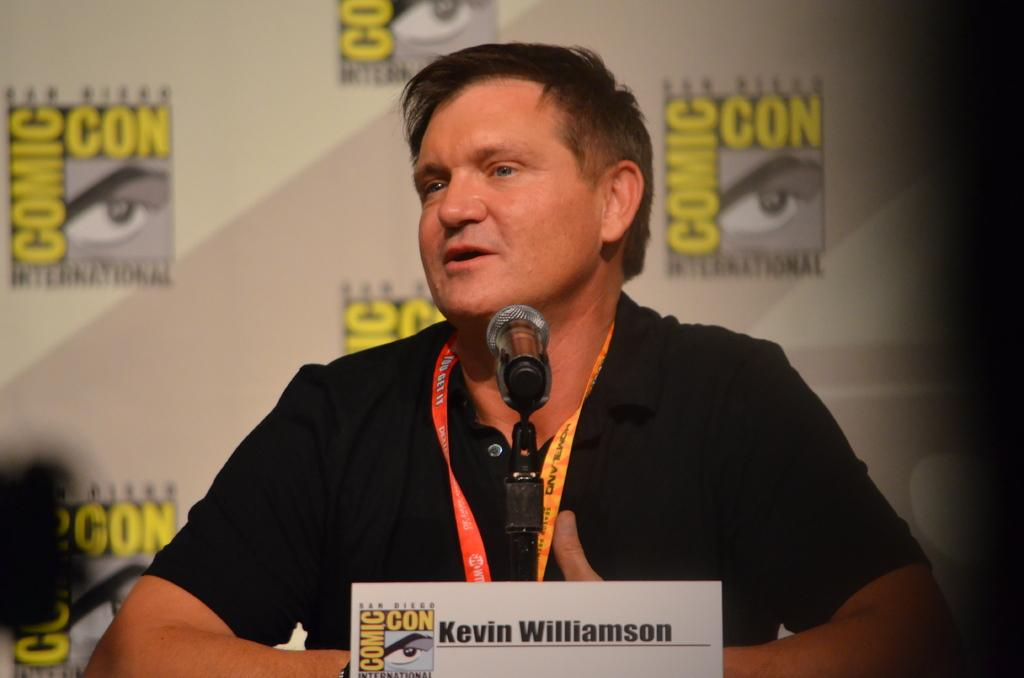What is the man in the image doing? There is a man sitting in the image. What is placed in front of the man? There is a name board and a microphone (mike) in front of the man. What can be seen in the background of the image? There is a board visible in the background of the image. How many nails can be seen holding the board in the background? There is no mention of nails in the image, and the board in the background does not appear to be held up by nails. 